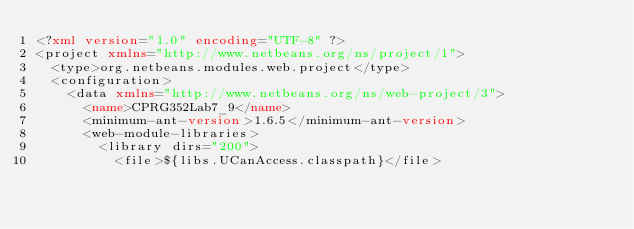Convert code to text. <code><loc_0><loc_0><loc_500><loc_500><_XML_><?xml version="1.0" encoding="UTF-8" ?>
<project xmlns="http://www.netbeans.org/ns/project/1">
  <type>org.netbeans.modules.web.project</type>
  <configuration>
    <data xmlns="http://www.netbeans.org/ns/web-project/3">
      <name>CPRG352Lab7_9</name>
      <minimum-ant-version>1.6.5</minimum-ant-version>
      <web-module-libraries>
        <library dirs="200">
          <file>${libs.UCanAccess.classpath}</file></code> 